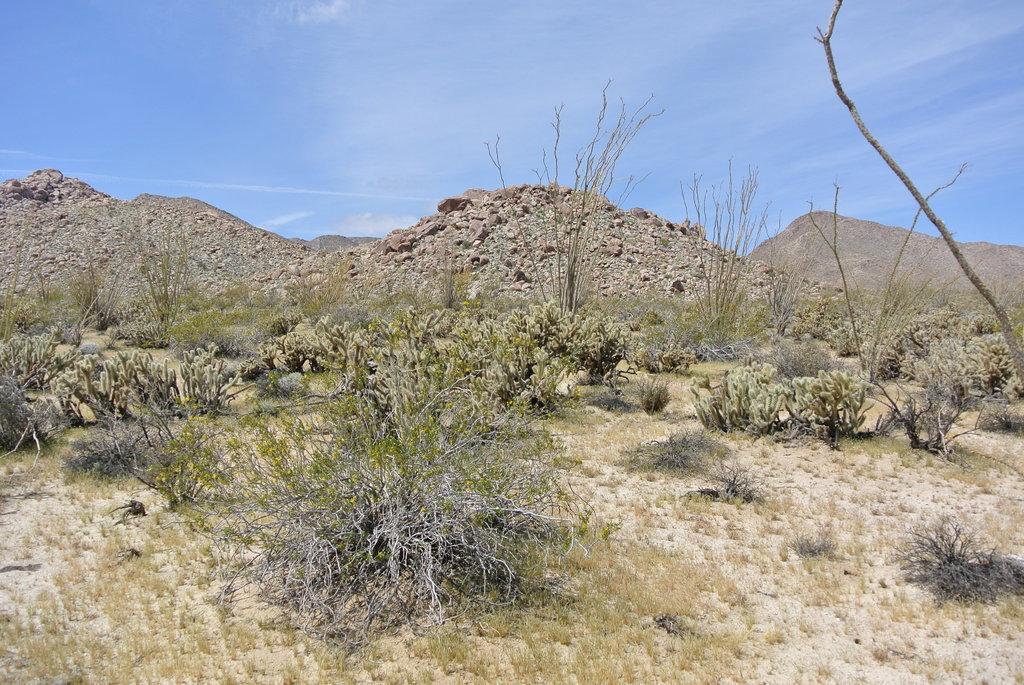Could you give a brief overview of what you see in this image? This image is clicked outside. In the front, we can see many plants. At the bottom, there is grass on the ground. In the background, there is soil and there are rocks. At the top, there is a sky. 